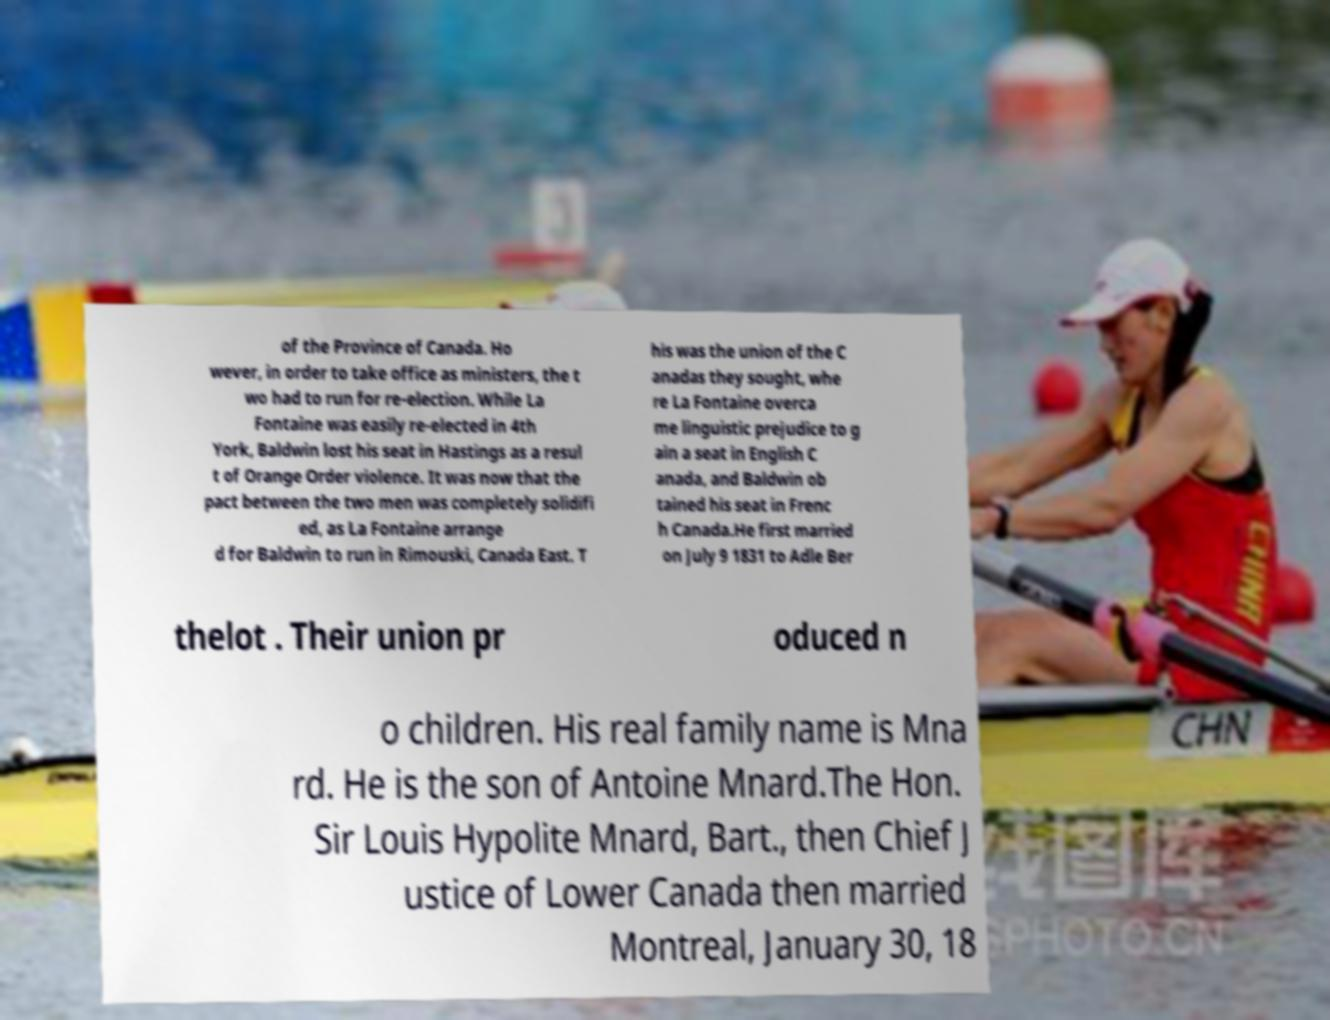What messages or text are displayed in this image? I need them in a readable, typed format. of the Province of Canada. Ho wever, in order to take office as ministers, the t wo had to run for re-election. While La Fontaine was easily re-elected in 4th York, Baldwin lost his seat in Hastings as a resul t of Orange Order violence. It was now that the pact between the two men was completely solidifi ed, as La Fontaine arrange d for Baldwin to run in Rimouski, Canada East. T his was the union of the C anadas they sought, whe re La Fontaine overca me linguistic prejudice to g ain a seat in English C anada, and Baldwin ob tained his seat in Frenc h Canada.He first married on July 9 1831 to Adle Ber thelot . Their union pr oduced n o children. His real family name is Mna rd. He is the son of Antoine Mnard.The Hon. Sir Louis Hypolite Mnard, Bart., then Chief J ustice of Lower Canada then married Montreal, January 30, 18 